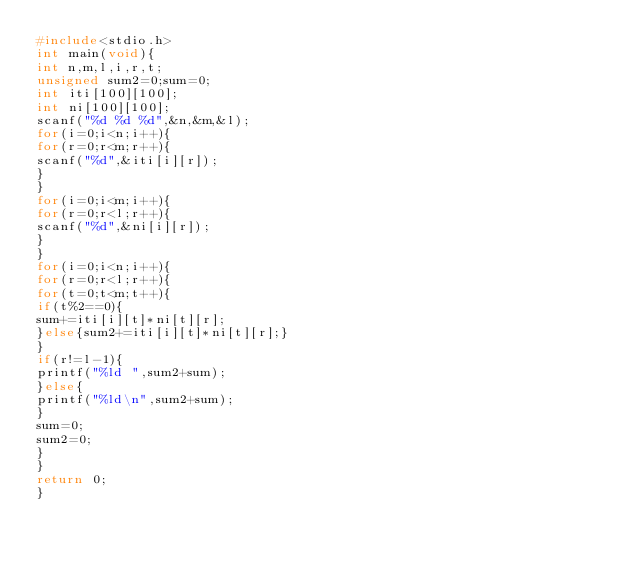Convert code to text. <code><loc_0><loc_0><loc_500><loc_500><_C_>#include<stdio.h>
int main(void){
int n,m,l,i,r,t;
unsigned sum2=0;sum=0;
int iti[100][100];
int ni[100][100];
scanf("%d %d %d",&n,&m,&l);
for(i=0;i<n;i++){
for(r=0;r<m;r++){
scanf("%d",&iti[i][r]);
}
}
for(i=0;i<m;i++){
for(r=0;r<l;r++){
scanf("%d",&ni[i][r]);
}
}
for(i=0;i<n;i++){
for(r=0;r<l;r++){
for(t=0;t<m;t++){
if(t%2==0){
sum+=iti[i][t]*ni[t][r];
}else{sum2+=iti[i][t]*ni[t][r];}
}
if(r!=l-1){
printf("%ld ",sum2+sum);
}else{
printf("%ld\n",sum2+sum);
}
sum=0;
sum2=0;
}
}
return 0;
}</code> 